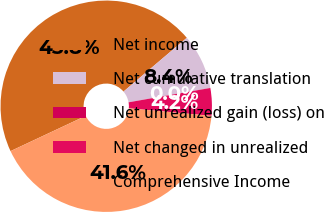<chart> <loc_0><loc_0><loc_500><loc_500><pie_chart><fcel>Net income<fcel>Net cumulative translation<fcel>Net unrealized gain (loss) on<fcel>Net changed in unrealized<fcel>Comprehensive Income<nl><fcel>45.77%<fcel>8.43%<fcel>0.01%<fcel>4.22%<fcel>41.56%<nl></chart> 